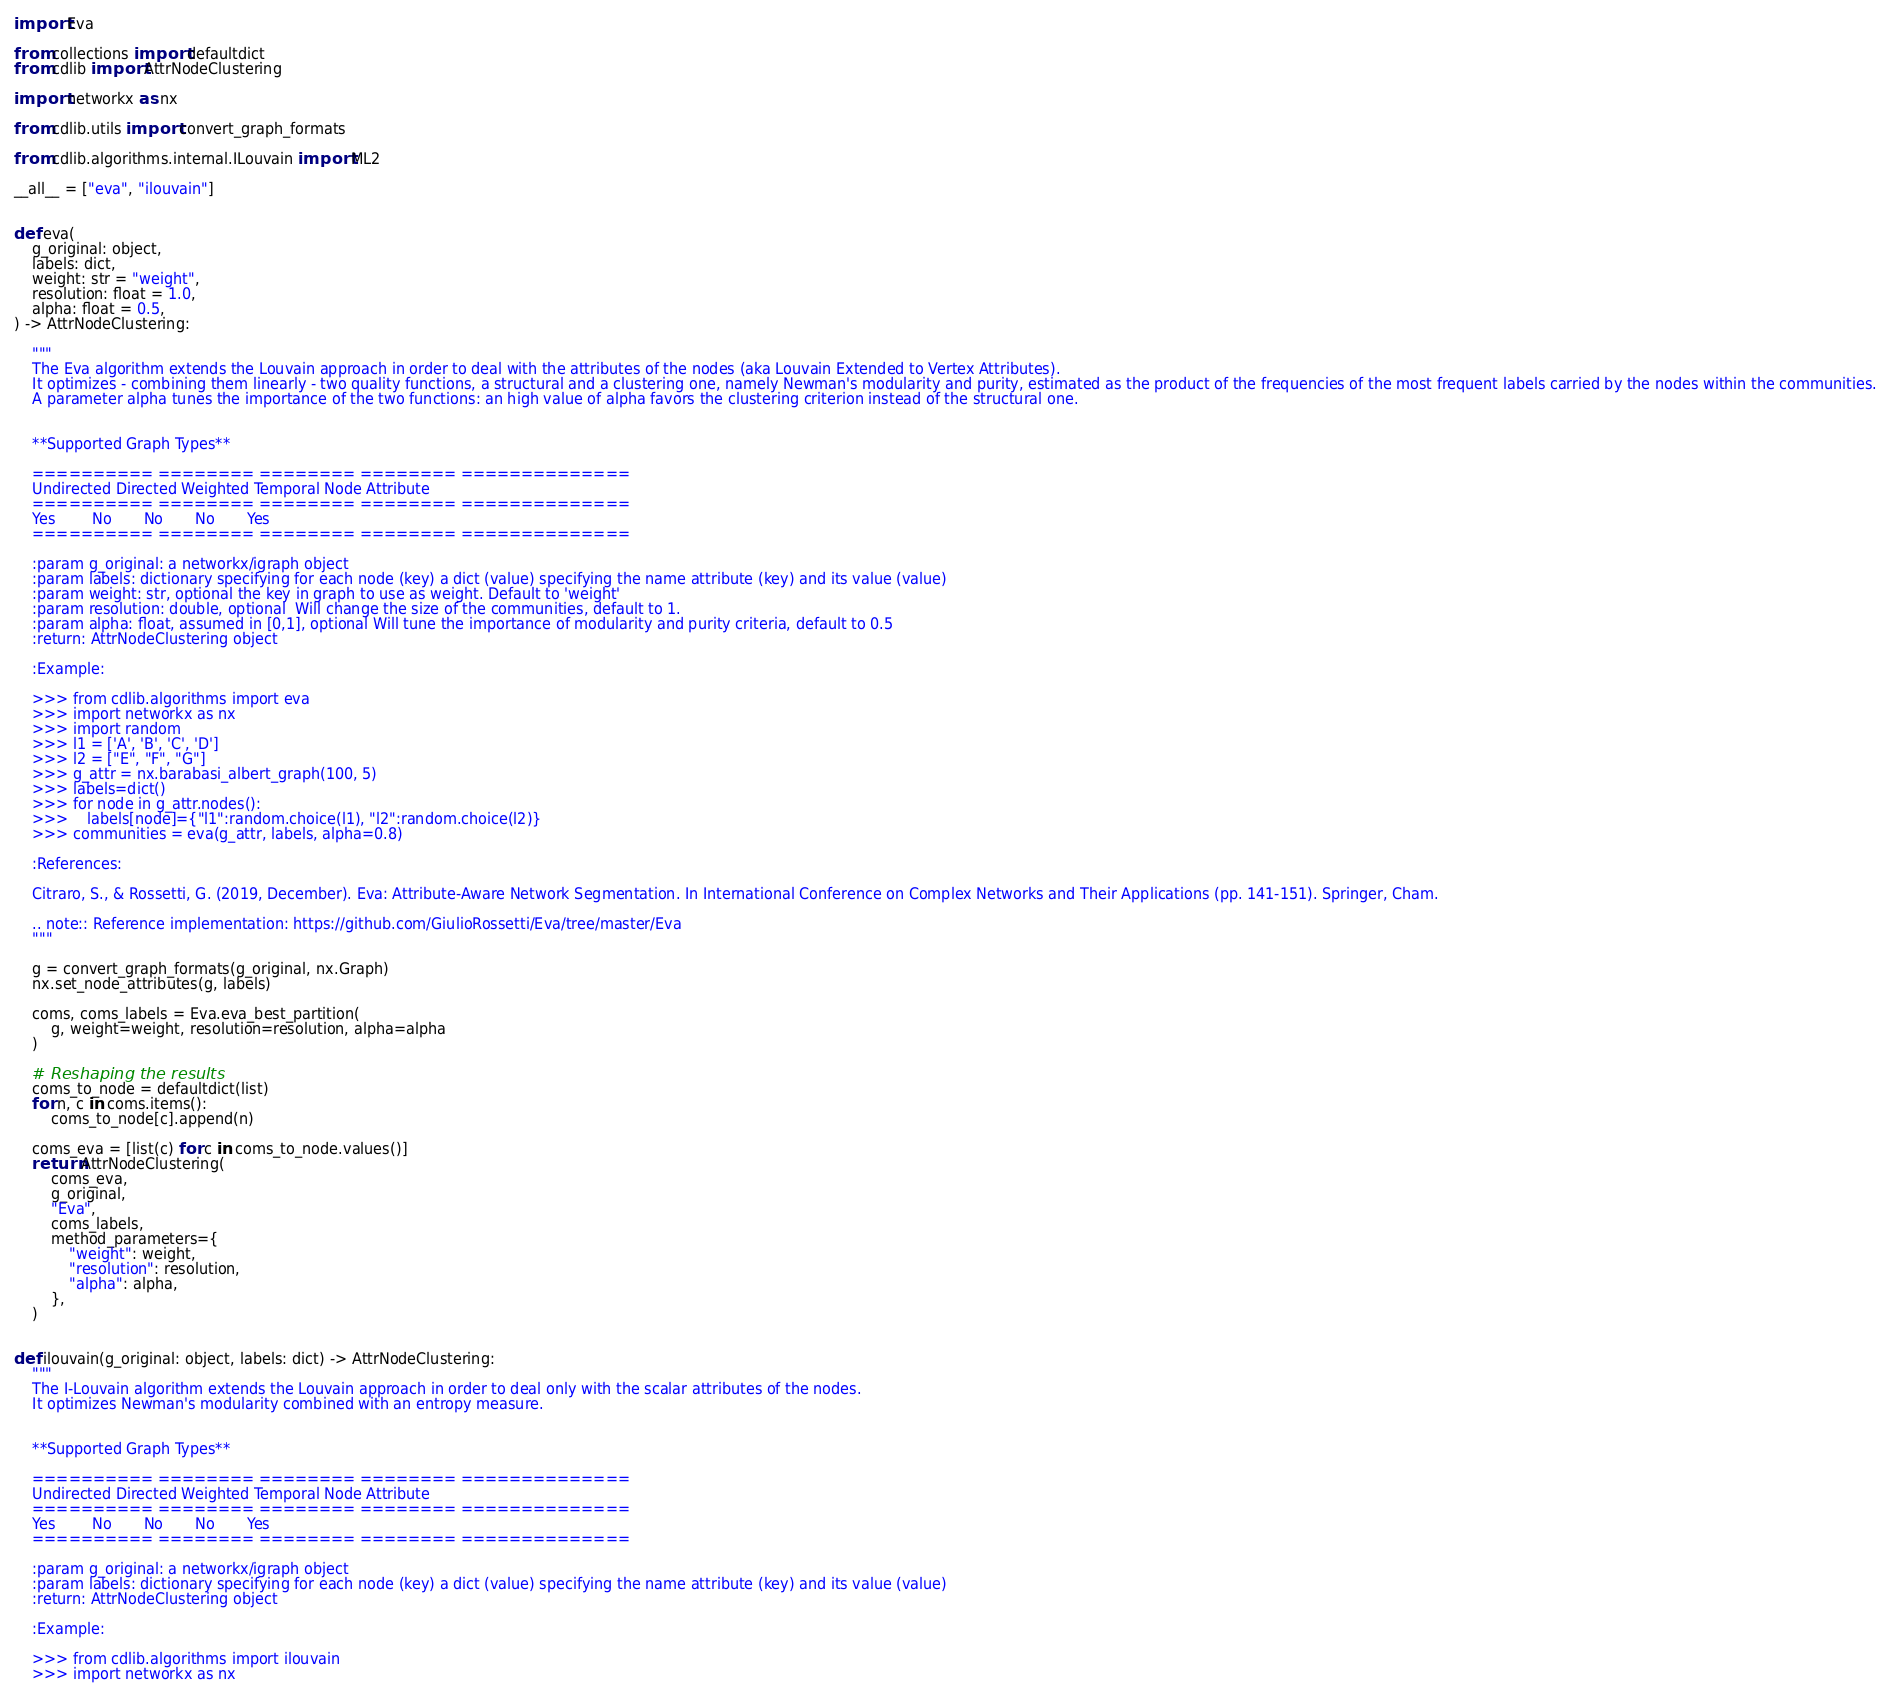Convert code to text. <code><loc_0><loc_0><loc_500><loc_500><_Python_>import Eva

from collections import defaultdict
from cdlib import AttrNodeClustering

import networkx as nx

from cdlib.utils import convert_graph_formats

from cdlib.algorithms.internal.ILouvain import ML2

__all__ = ["eva", "ilouvain"]


def eva(
    g_original: object,
    labels: dict,
    weight: str = "weight",
    resolution: float = 1.0,
    alpha: float = 0.5,
) -> AttrNodeClustering:

    """
    The Eva algorithm extends the Louvain approach in order to deal with the attributes of the nodes (aka Louvain Extended to Vertex Attributes).
    It optimizes - combining them linearly - two quality functions, a structural and a clustering one, namely Newman's modularity and purity, estimated as the product of the frequencies of the most frequent labels carried by the nodes within the communities.
    A parameter alpha tunes the importance of the two functions: an high value of alpha favors the clustering criterion instead of the structural one.


    **Supported Graph Types**

    ========== ======== ======== ======== ==============
    Undirected Directed Weighted Temporal Node Attribute
    ========== ======== ======== ======== ==============
    Yes        No       No       No       Yes
    ========== ======== ======== ======== ==============

    :param g_original: a networkx/igraph object
    :param labels: dictionary specifying for each node (key) a dict (value) specifying the name attribute (key) and its value (value)
    :param weight: str, optional the key in graph to use as weight. Default to 'weight'
    :param resolution: double, optional  Will change the size of the communities, default to 1.
    :param alpha: float, assumed in [0,1], optional Will tune the importance of modularity and purity criteria, default to 0.5
    :return: AttrNodeClustering object

    :Example:

    >>> from cdlib.algorithms import eva
    >>> import networkx as nx
    >>> import random
    >>> l1 = ['A', 'B', 'C', 'D']
    >>> l2 = ["E", "F", "G"]
    >>> g_attr = nx.barabasi_albert_graph(100, 5)
    >>> labels=dict()
    >>> for node in g_attr.nodes():
    >>>    labels[node]={"l1":random.choice(l1), "l2":random.choice(l2)}
    >>> communities = eva(g_attr, labels, alpha=0.8)

    :References:

    Citraro, S., & Rossetti, G. (2019, December). Eva: Attribute-Aware Network Segmentation. In International Conference on Complex Networks and Their Applications (pp. 141-151). Springer, Cham.

    .. note:: Reference implementation: https://github.com/GiulioRossetti/Eva/tree/master/Eva
    """

    g = convert_graph_formats(g_original, nx.Graph)
    nx.set_node_attributes(g, labels)

    coms, coms_labels = Eva.eva_best_partition(
        g, weight=weight, resolution=resolution, alpha=alpha
    )

    # Reshaping the results
    coms_to_node = defaultdict(list)
    for n, c in coms.items():
        coms_to_node[c].append(n)

    coms_eva = [list(c) for c in coms_to_node.values()]
    return AttrNodeClustering(
        coms_eva,
        g_original,
        "Eva",
        coms_labels,
        method_parameters={
            "weight": weight,
            "resolution": resolution,
            "alpha": alpha,
        },
    )


def ilouvain(g_original: object, labels: dict) -> AttrNodeClustering:
    """
    The I-Louvain algorithm extends the Louvain approach in order to deal only with the scalar attributes of the nodes.
    It optimizes Newman's modularity combined with an entropy measure.


    **Supported Graph Types**

    ========== ======== ======== ======== ==============
    Undirected Directed Weighted Temporal Node Attribute
    ========== ======== ======== ======== ==============
    Yes        No       No       No       Yes
    ========== ======== ======== ======== ==============

    :param g_original: a networkx/igraph object
    :param labels: dictionary specifying for each node (key) a dict (value) specifying the name attribute (key) and its value (value)
    :return: AttrNodeClustering object

    :Example:

    >>> from cdlib.algorithms import ilouvain
    >>> import networkx as nx</code> 